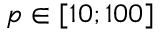Convert formula to latex. <formula><loc_0><loc_0><loc_500><loc_500>p [ 1 0 ; 1 0 0 ]</formula> 